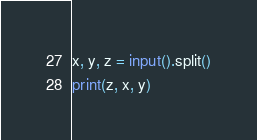<code> <loc_0><loc_0><loc_500><loc_500><_Python_>x, y, z = input().split()
print(z, x, y)</code> 